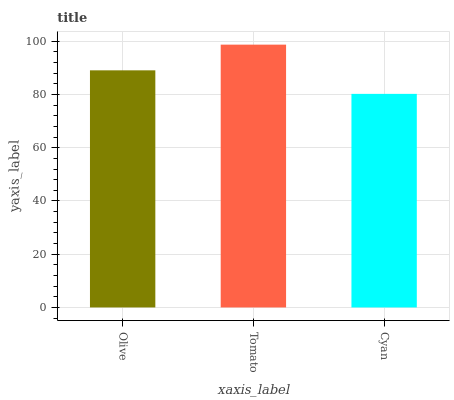Is Cyan the minimum?
Answer yes or no. Yes. Is Tomato the maximum?
Answer yes or no. Yes. Is Tomato the minimum?
Answer yes or no. No. Is Cyan the maximum?
Answer yes or no. No. Is Tomato greater than Cyan?
Answer yes or no. Yes. Is Cyan less than Tomato?
Answer yes or no. Yes. Is Cyan greater than Tomato?
Answer yes or no. No. Is Tomato less than Cyan?
Answer yes or no. No. Is Olive the high median?
Answer yes or no. Yes. Is Olive the low median?
Answer yes or no. Yes. Is Cyan the high median?
Answer yes or no. No. Is Tomato the low median?
Answer yes or no. No. 